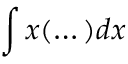<formula> <loc_0><loc_0><loc_500><loc_500>\int x ( \dots ) d x</formula> 